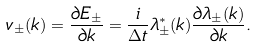Convert formula to latex. <formula><loc_0><loc_0><loc_500><loc_500>v _ { \pm } ( k ) = \frac { \partial E _ { \pm } } { \partial k } = \frac { i } { \Delta t } \lambda _ { \pm } ^ { \ast } ( k ) \frac { \partial \lambda _ { \pm } ( k ) } { \partial k } .</formula> 